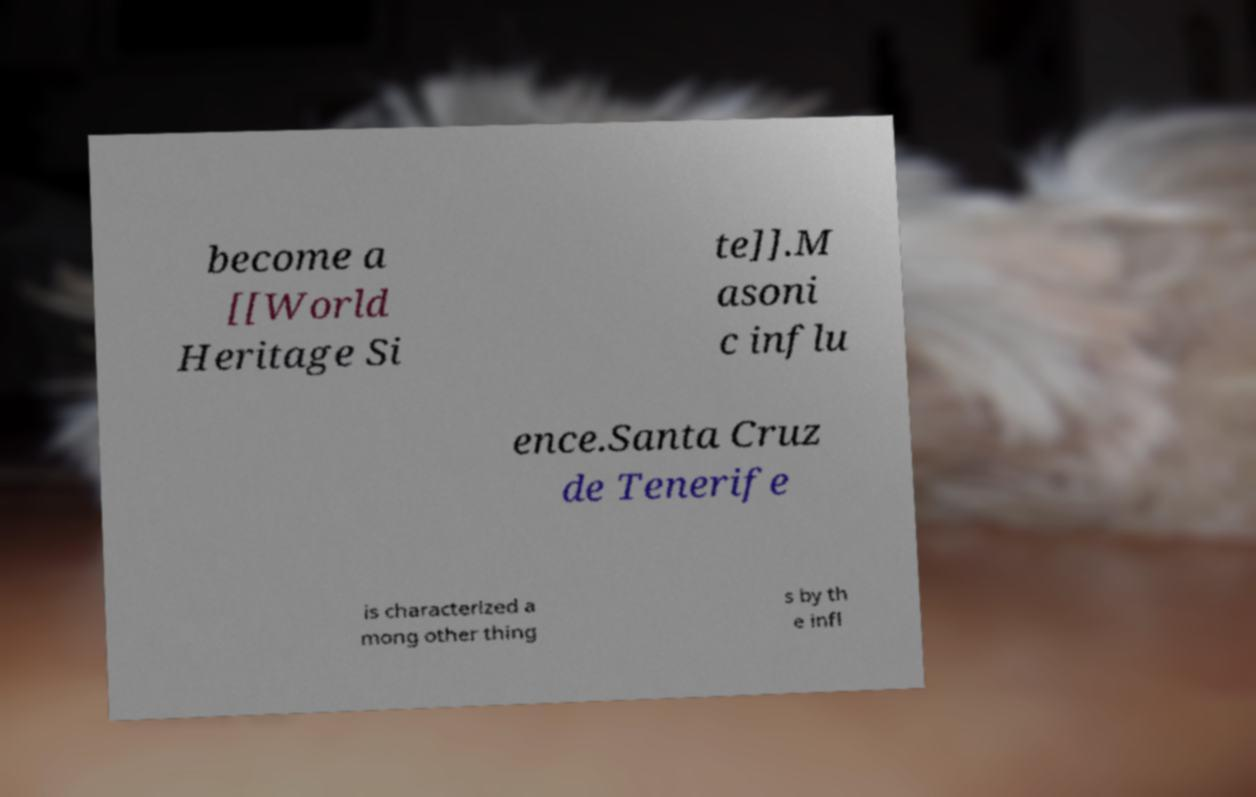Please identify and transcribe the text found in this image. become a [[World Heritage Si te]].M asoni c influ ence.Santa Cruz de Tenerife is characterized a mong other thing s by th e infl 